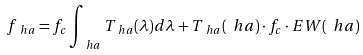<formula> <loc_0><loc_0><loc_500><loc_500>f _ { \ h a } = f _ { c } \int _ { \ h a } T _ { \ h a } ( \lambda ) d \lambda + T _ { \ h a } ( \ h a ) \cdot f _ { c } \cdot E W ( \ h a )</formula> 